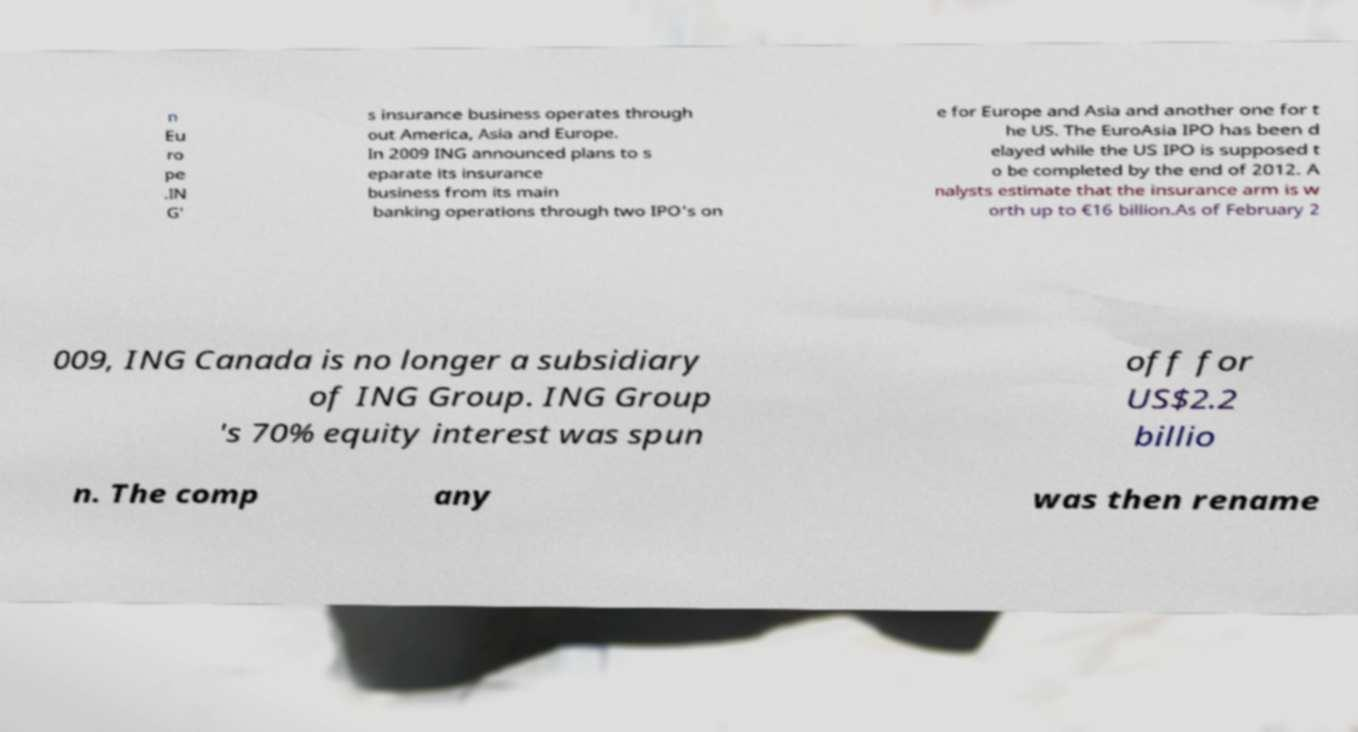Could you assist in decoding the text presented in this image and type it out clearly? n Eu ro pe .IN G' s insurance business operates through out America, Asia and Europe. In 2009 ING announced plans to s eparate its insurance business from its main banking operations through two IPO's on e for Europe and Asia and another one for t he US. The EuroAsia IPO has been d elayed while the US IPO is supposed t o be completed by the end of 2012. A nalysts estimate that the insurance arm is w orth up to €16 billion.As of February 2 009, ING Canada is no longer a subsidiary of ING Group. ING Group 's 70% equity interest was spun off for US$2.2 billio n. The comp any was then rename 